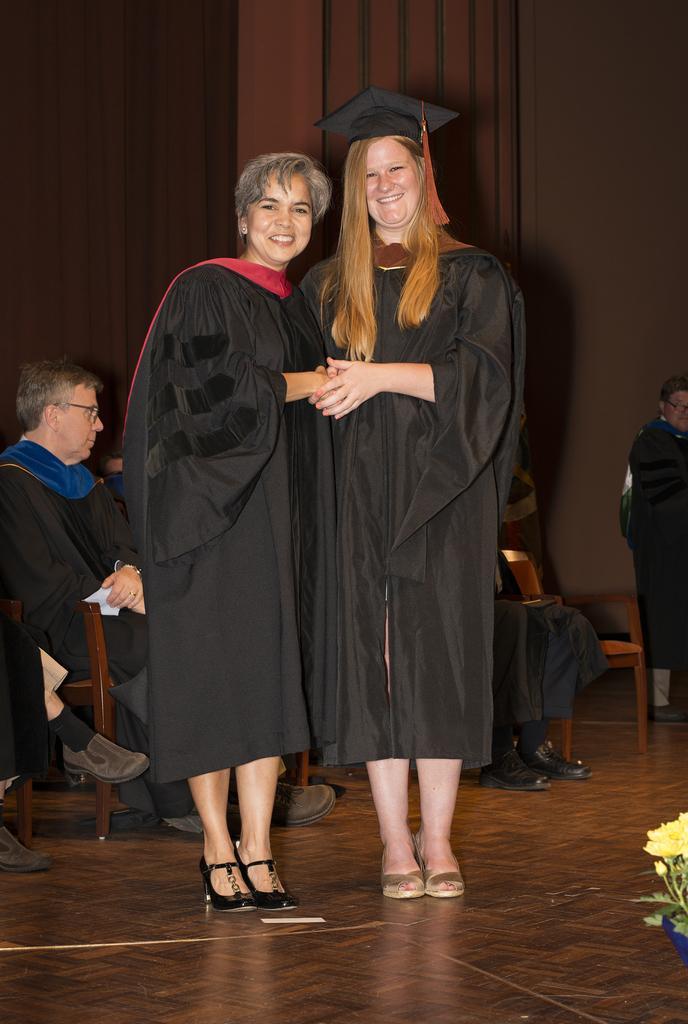Could you give a brief overview of what you see in this image? In this given picture, I can see two women's standing next to each other and shaking hands and behind this two people, I can see other person, Who is sitting and i can see a floor after that i can see a flower and behind this people, I can see a curtain a brown color curtain and a mat. 